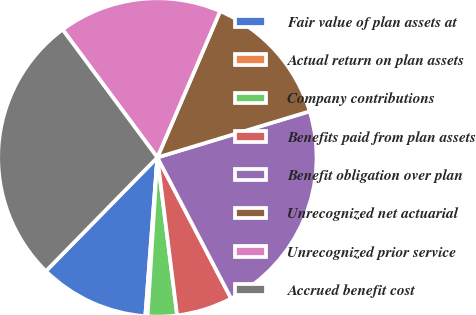Convert chart to OTSL. <chart><loc_0><loc_0><loc_500><loc_500><pie_chart><fcel>Fair value of plan assets at<fcel>Actual return on plan assets<fcel>Company contributions<fcel>Benefits paid from plan assets<fcel>Benefit obligation over plan<fcel>Unrecognized net actuarial<fcel>Unrecognized prior service<fcel>Accrued benefit cost<nl><fcel>11.14%<fcel>0.23%<fcel>2.96%<fcel>5.69%<fcel>22.01%<fcel>13.87%<fcel>16.6%<fcel>27.51%<nl></chart> 